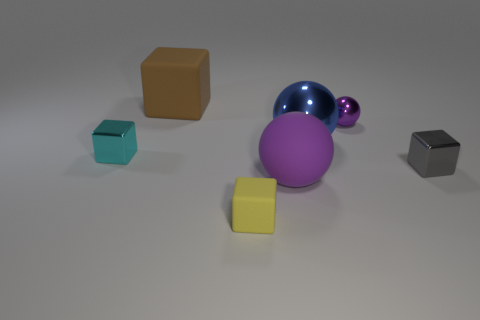There is a matte ball; does it have the same color as the ball that is to the right of the blue sphere?
Your answer should be compact. Yes. The rubber thing that is the same color as the small sphere is what shape?
Your answer should be very brief. Sphere. Is the small sphere the same color as the matte ball?
Make the answer very short. Yes. What number of objects are either large spheres behind the large purple rubber thing or small blue matte things?
Your response must be concise. 1. There is a blue thing that is made of the same material as the cyan thing; what is its size?
Provide a short and direct response. Large. Is the number of yellow objects left of the tiny gray shiny block greater than the number of small purple blocks?
Give a very brief answer. Yes. There is a cyan object; is it the same shape as the matte thing to the right of the yellow matte cube?
Offer a very short reply. No. How many big things are brown matte spheres or yellow rubber things?
Keep it short and to the point. 0. What is the size of the matte object that is the same color as the tiny shiny ball?
Give a very brief answer. Large. What color is the big sphere that is behind the shiny block in front of the small cyan cube?
Offer a very short reply. Blue. 